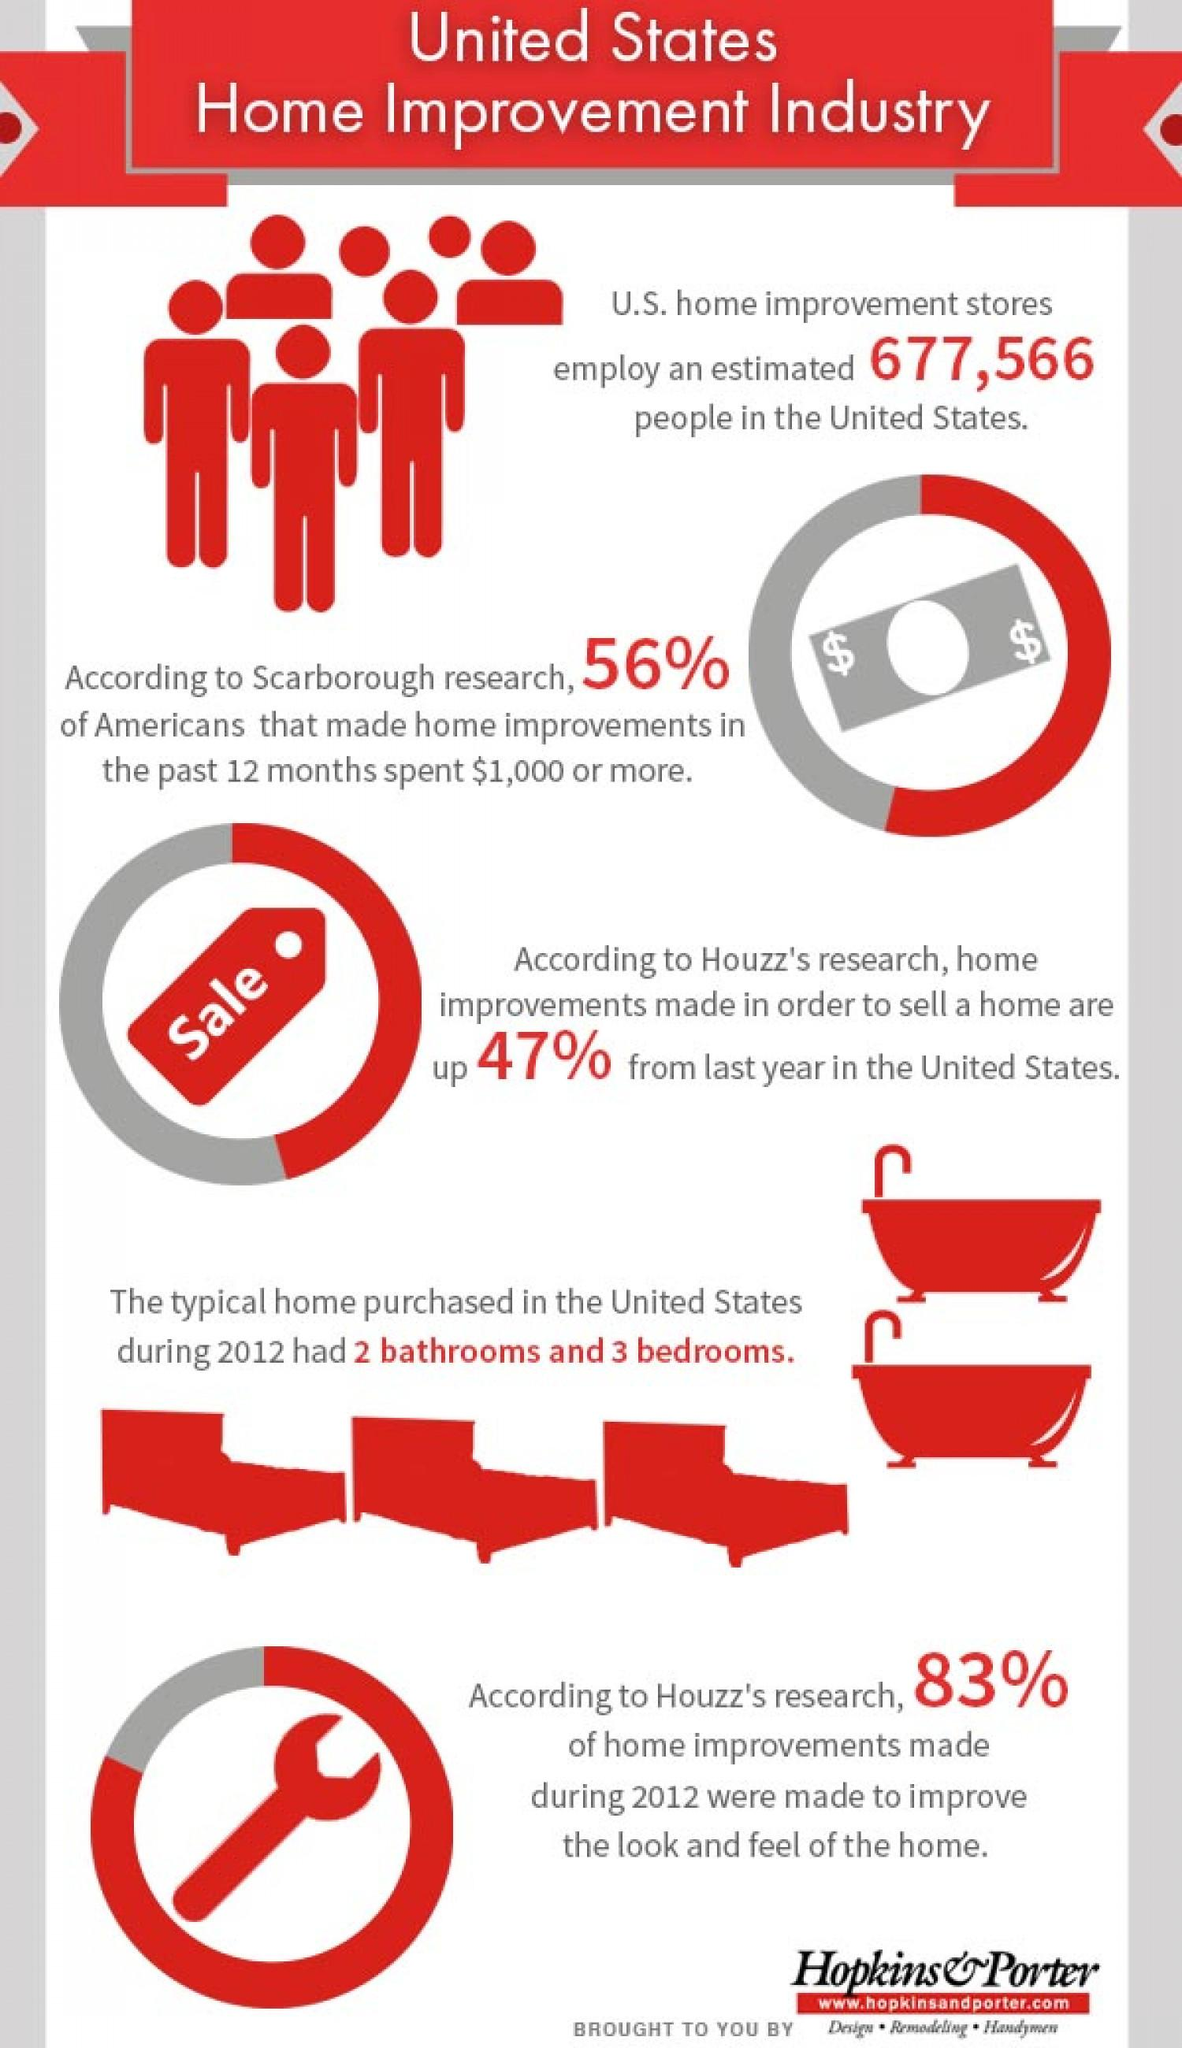Identify some key points in this picture. Houzz's research revealed a significant increase in home improvements in the United States. 